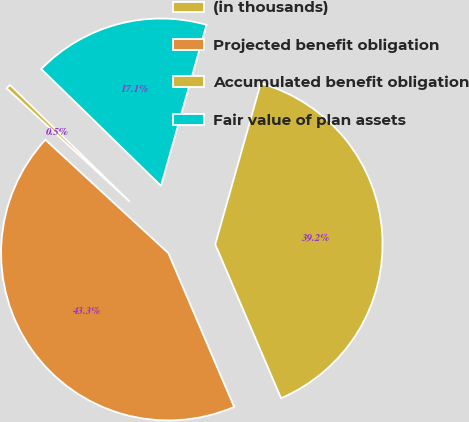<chart> <loc_0><loc_0><loc_500><loc_500><pie_chart><fcel>(in thousands)<fcel>Projected benefit obligation<fcel>Accumulated benefit obligation<fcel>Fair value of plan assets<nl><fcel>0.45%<fcel>43.28%<fcel>39.18%<fcel>17.08%<nl></chart> 